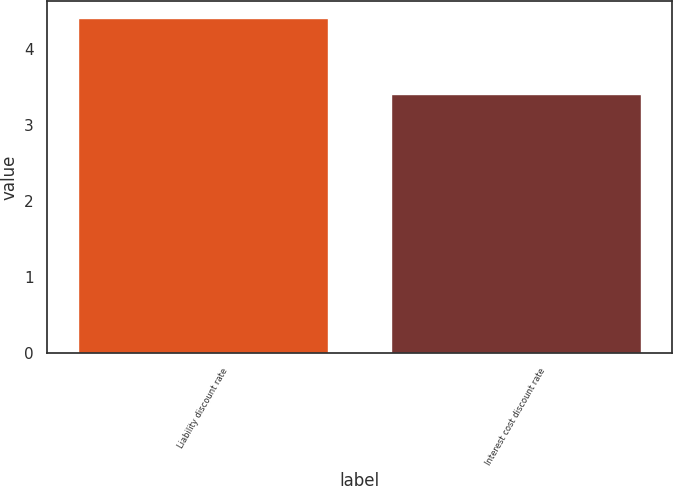<chart> <loc_0><loc_0><loc_500><loc_500><bar_chart><fcel>Liability discount rate<fcel>Interest cost discount rate<nl><fcel>4.4<fcel>3.4<nl></chart> 